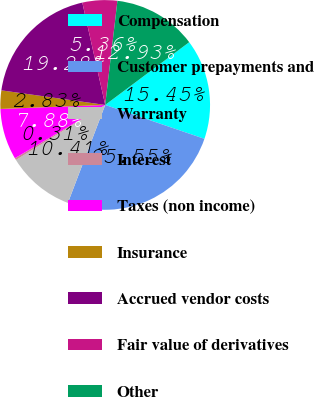<chart> <loc_0><loc_0><loc_500><loc_500><pie_chart><fcel>Compensation<fcel>Customer prepayments and<fcel>Warranty<fcel>Interest<fcel>Taxes (non income)<fcel>Insurance<fcel>Accrued vendor costs<fcel>Fair value of derivatives<fcel>Other<nl><fcel>15.45%<fcel>25.55%<fcel>10.41%<fcel>0.31%<fcel>7.88%<fcel>2.83%<fcel>19.28%<fcel>5.36%<fcel>12.93%<nl></chart> 